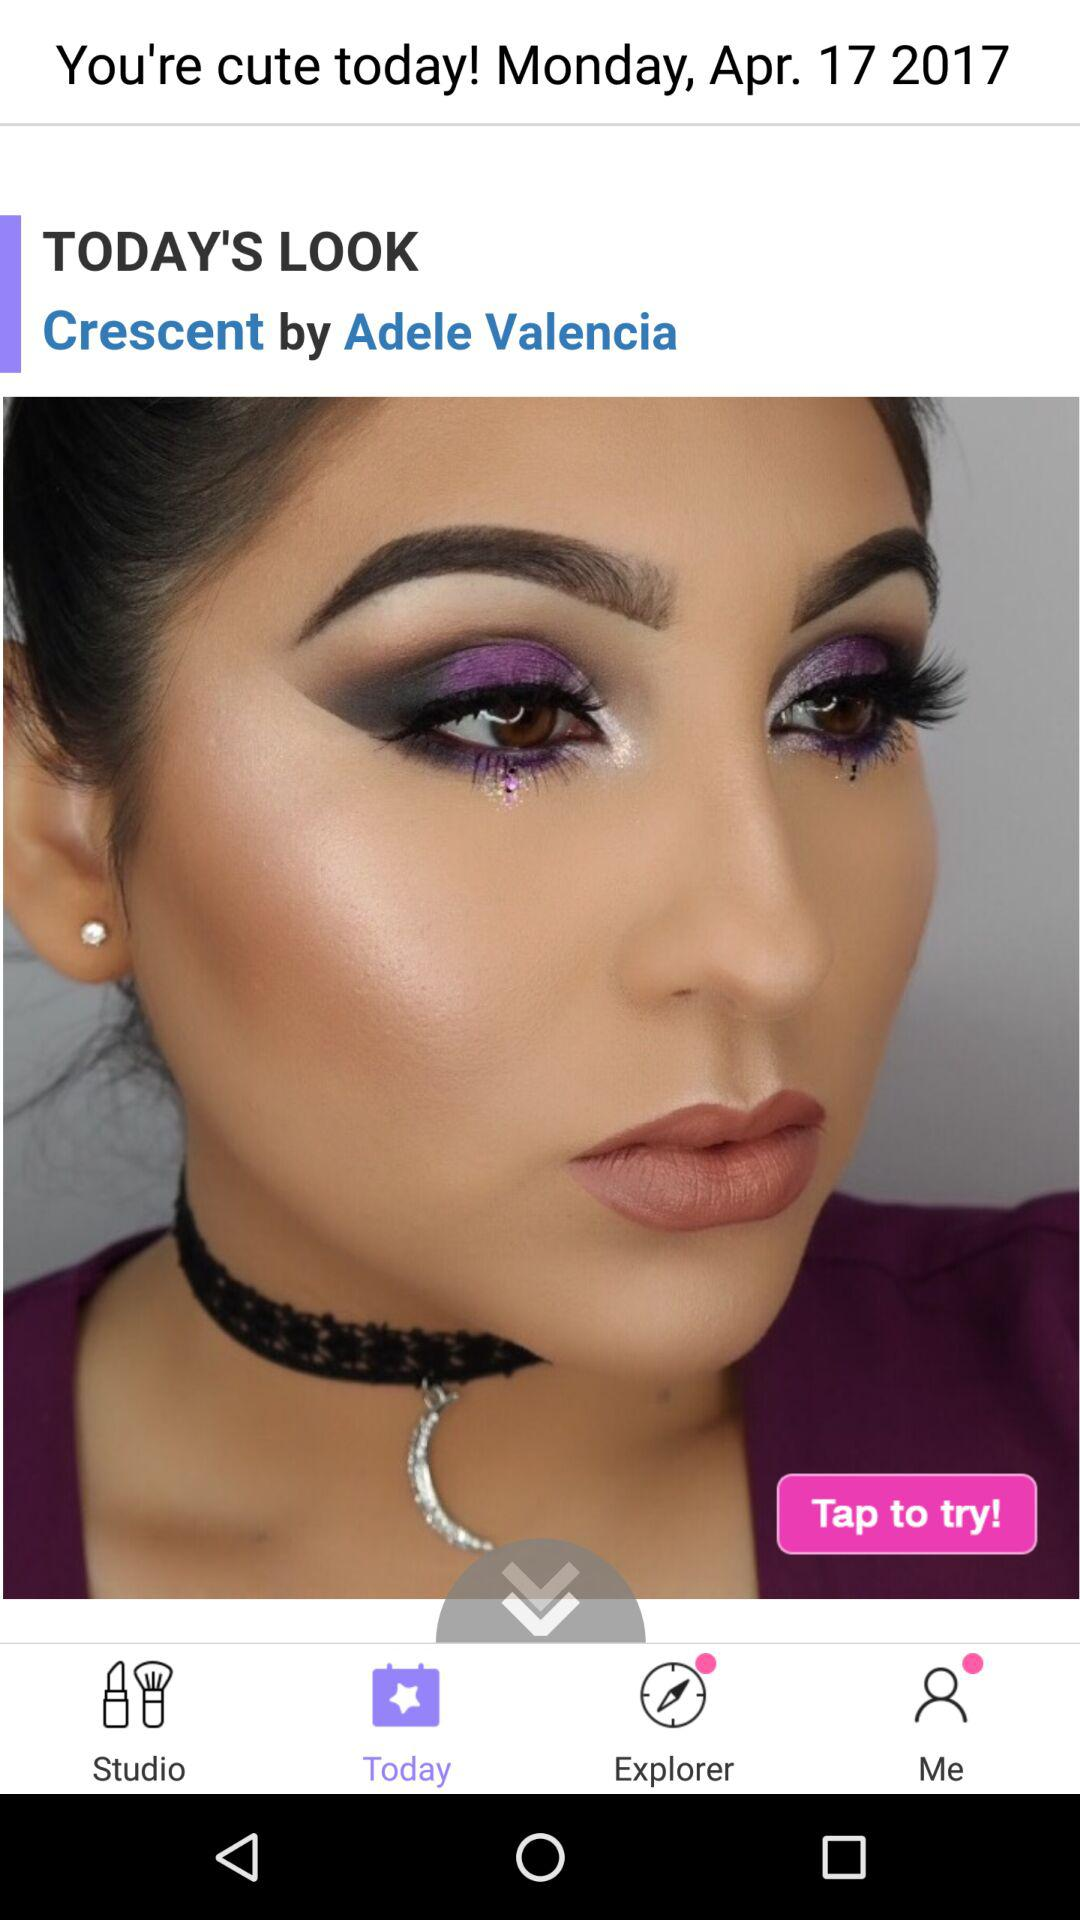What weekday is April 17? The weekday is "Monday". 